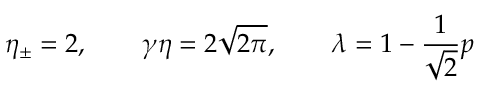Convert formula to latex. <formula><loc_0><loc_0><loc_500><loc_500>\eta _ { \pm } = 2 , \quad \gamma \eta = 2 \sqrt { 2 \pi } , \quad \lambda = 1 - \frac { 1 } { \sqrt { 2 } } p</formula> 